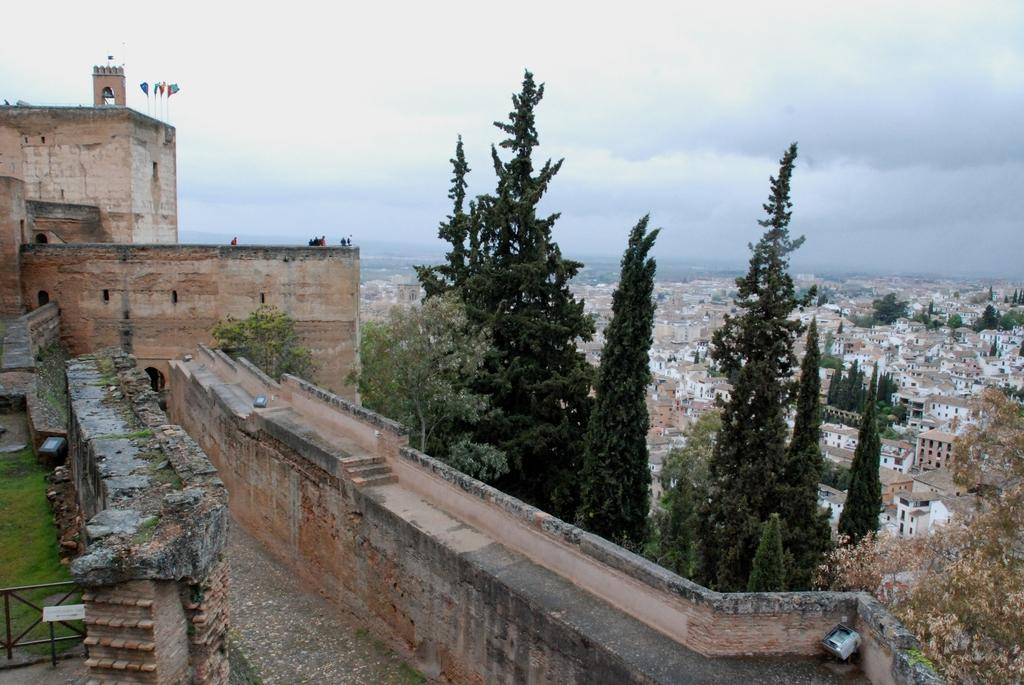What type of structure is located on the left side of the image? There is a castle on the left side of the image. What is in front of the castle? Trees are in front of the castle. What can be seen on the right side of the image? There is a city with many buildings on the right side of the image. What is visible in the sky in the image? The sky is visible in the image, and clouds are present. What type of leather is used to make the cork in the image? There is no leather or cork present in the image. How many cars are parked in front of the castle in the image? There are no cars present in the image; only trees are in front of the castle. 